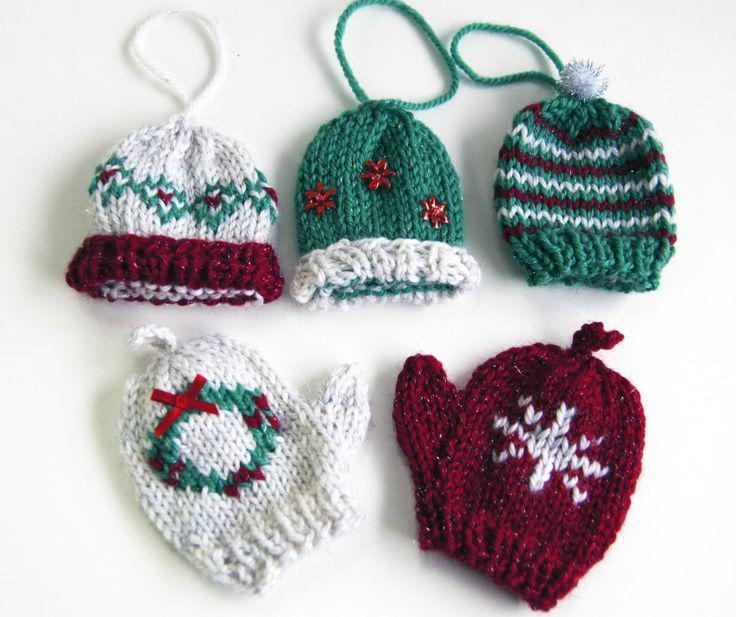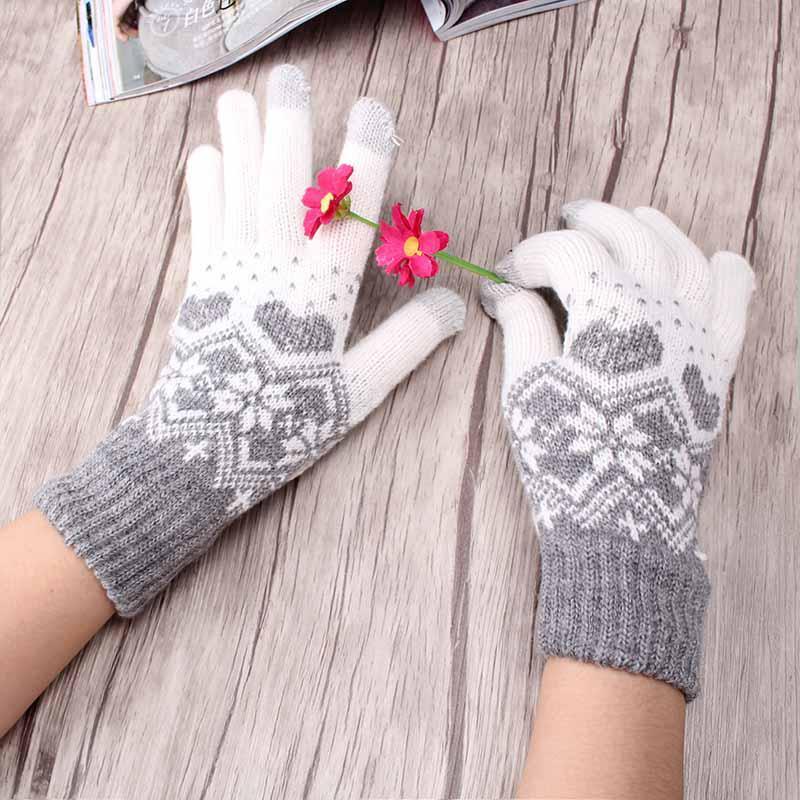The first image is the image on the left, the second image is the image on the right. For the images shown, is this caption "One pair of knit gloves are being worn on someone's hands." true? Answer yes or no. Yes. The first image is the image on the left, the second image is the image on the right. Assess this claim about the two images: "No image shows more than one pair of """"mittens"""" or any other wearable item, and at least one mitten pair has gray and dark red colors.". Correct or not? Answer yes or no. No. 